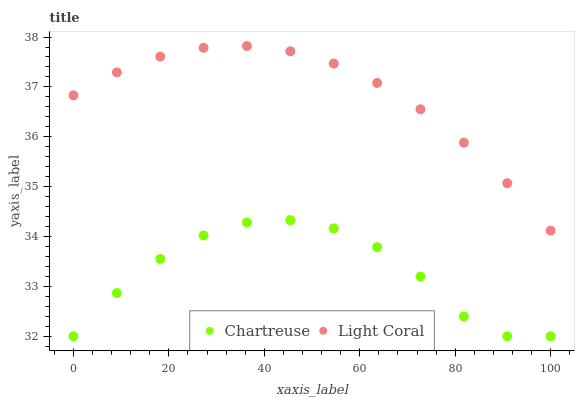Does Chartreuse have the minimum area under the curve?
Answer yes or no. Yes. Does Light Coral have the maximum area under the curve?
Answer yes or no. Yes. Does Chartreuse have the maximum area under the curve?
Answer yes or no. No. Is Light Coral the smoothest?
Answer yes or no. Yes. Is Chartreuse the roughest?
Answer yes or no. Yes. Is Chartreuse the smoothest?
Answer yes or no. No. Does Chartreuse have the lowest value?
Answer yes or no. Yes. Does Light Coral have the highest value?
Answer yes or no. Yes. Does Chartreuse have the highest value?
Answer yes or no. No. Is Chartreuse less than Light Coral?
Answer yes or no. Yes. Is Light Coral greater than Chartreuse?
Answer yes or no. Yes. Does Chartreuse intersect Light Coral?
Answer yes or no. No. 